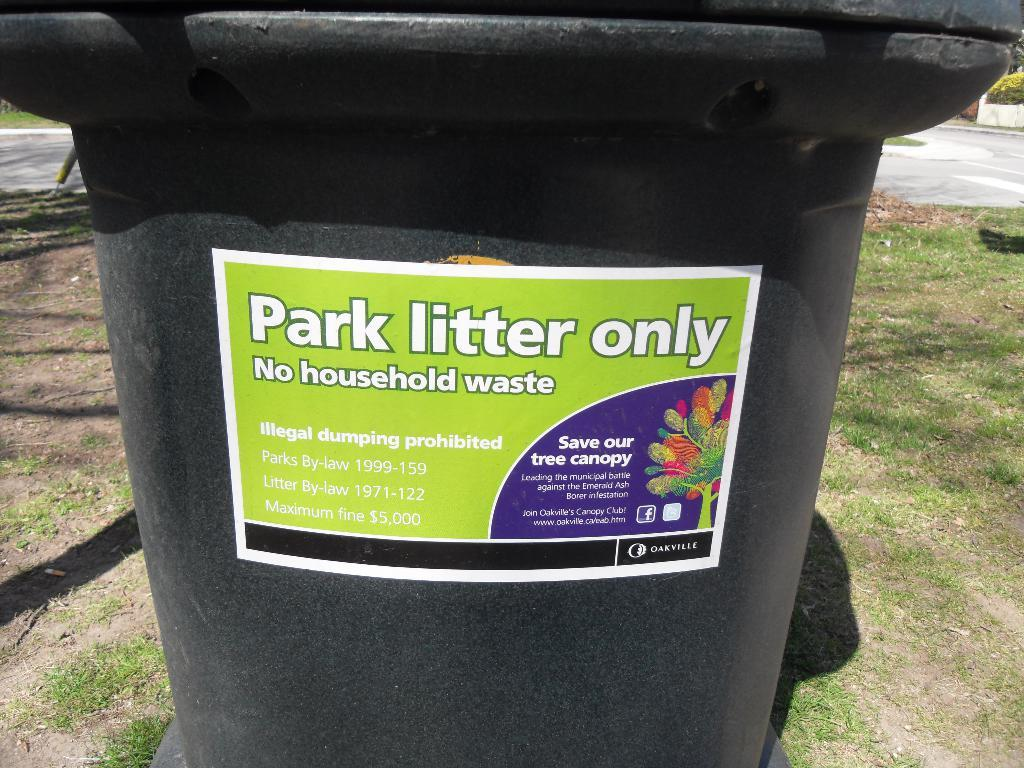<image>
Describe the image concisely. A plastic can has a sticker that reads, "park litter only." 